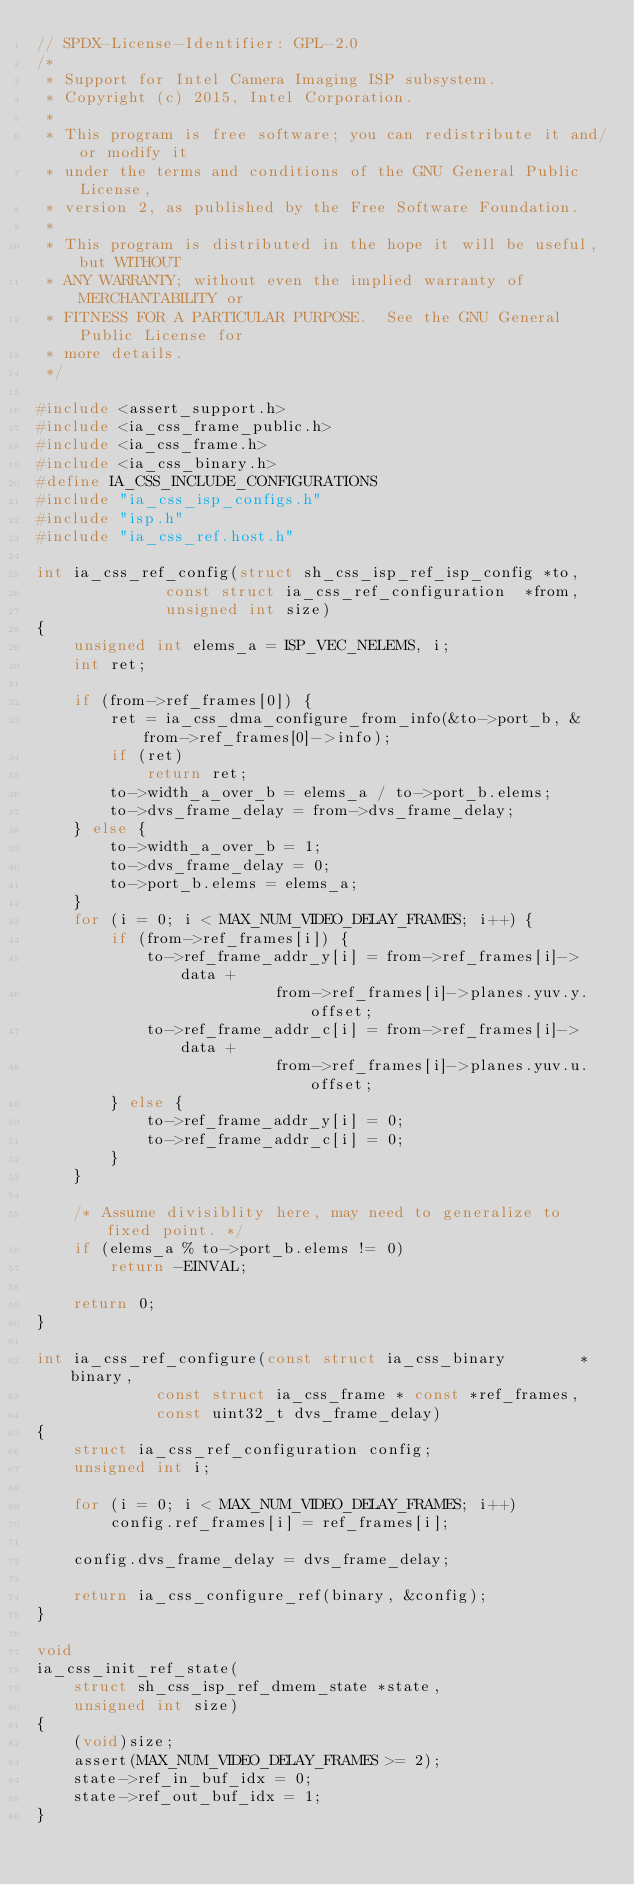Convert code to text. <code><loc_0><loc_0><loc_500><loc_500><_C_>// SPDX-License-Identifier: GPL-2.0
/*
 * Support for Intel Camera Imaging ISP subsystem.
 * Copyright (c) 2015, Intel Corporation.
 *
 * This program is free software; you can redistribute it and/or modify it
 * under the terms and conditions of the GNU General Public License,
 * version 2, as published by the Free Software Foundation.
 *
 * This program is distributed in the hope it will be useful, but WITHOUT
 * ANY WARRANTY; without even the implied warranty of MERCHANTABILITY or
 * FITNESS FOR A PARTICULAR PURPOSE.  See the GNU General Public License for
 * more details.
 */

#include <assert_support.h>
#include <ia_css_frame_public.h>
#include <ia_css_frame.h>
#include <ia_css_binary.h>
#define IA_CSS_INCLUDE_CONFIGURATIONS
#include "ia_css_isp_configs.h"
#include "isp.h"
#include "ia_css_ref.host.h"

int ia_css_ref_config(struct sh_css_isp_ref_isp_config *to,
		      const struct ia_css_ref_configuration  *from,
		      unsigned int size)
{
	unsigned int elems_a = ISP_VEC_NELEMS, i;
	int ret;

	if (from->ref_frames[0]) {
		ret = ia_css_dma_configure_from_info(&to->port_b, &from->ref_frames[0]->info);
		if (ret)
			return ret;
		to->width_a_over_b = elems_a / to->port_b.elems;
		to->dvs_frame_delay = from->dvs_frame_delay;
	} else {
		to->width_a_over_b = 1;
		to->dvs_frame_delay = 0;
		to->port_b.elems = elems_a;
	}
	for (i = 0; i < MAX_NUM_VIDEO_DELAY_FRAMES; i++) {
		if (from->ref_frames[i]) {
			to->ref_frame_addr_y[i] = from->ref_frames[i]->data +
						  from->ref_frames[i]->planes.yuv.y.offset;
			to->ref_frame_addr_c[i] = from->ref_frames[i]->data +
						  from->ref_frames[i]->planes.yuv.u.offset;
		} else {
			to->ref_frame_addr_y[i] = 0;
			to->ref_frame_addr_c[i] = 0;
		}
	}

	/* Assume divisiblity here, may need to generalize to fixed point. */
	if (elems_a % to->port_b.elems != 0)
		return -EINVAL;

	return 0;
}

int ia_css_ref_configure(const struct ia_css_binary        *binary,
			 const struct ia_css_frame * const *ref_frames,
			 const uint32_t dvs_frame_delay)
{
	struct ia_css_ref_configuration config;
	unsigned int i;

	for (i = 0; i < MAX_NUM_VIDEO_DELAY_FRAMES; i++)
		config.ref_frames[i] = ref_frames[i];

	config.dvs_frame_delay = dvs_frame_delay;

	return ia_css_configure_ref(binary, &config);
}

void
ia_css_init_ref_state(
    struct sh_css_isp_ref_dmem_state *state,
    unsigned int size)
{
	(void)size;
	assert(MAX_NUM_VIDEO_DELAY_FRAMES >= 2);
	state->ref_in_buf_idx = 0;
	state->ref_out_buf_idx = 1;
}
</code> 